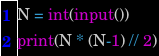<code> <loc_0><loc_0><loc_500><loc_500><_Python_>N = int(input())
print(N * (N-1) // 2)</code> 